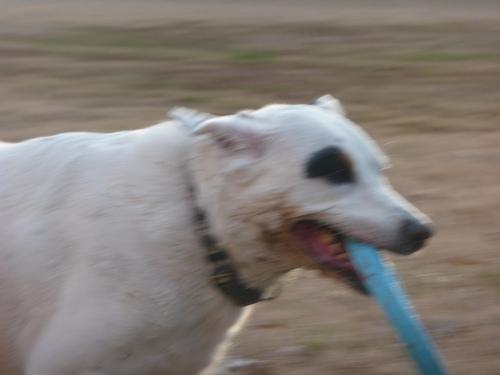Question: what animal is it?
Choices:
A. Dog.
B. Cat.
C. Hamster.
D. Gerbil.
Answer with the letter. Answer: A 